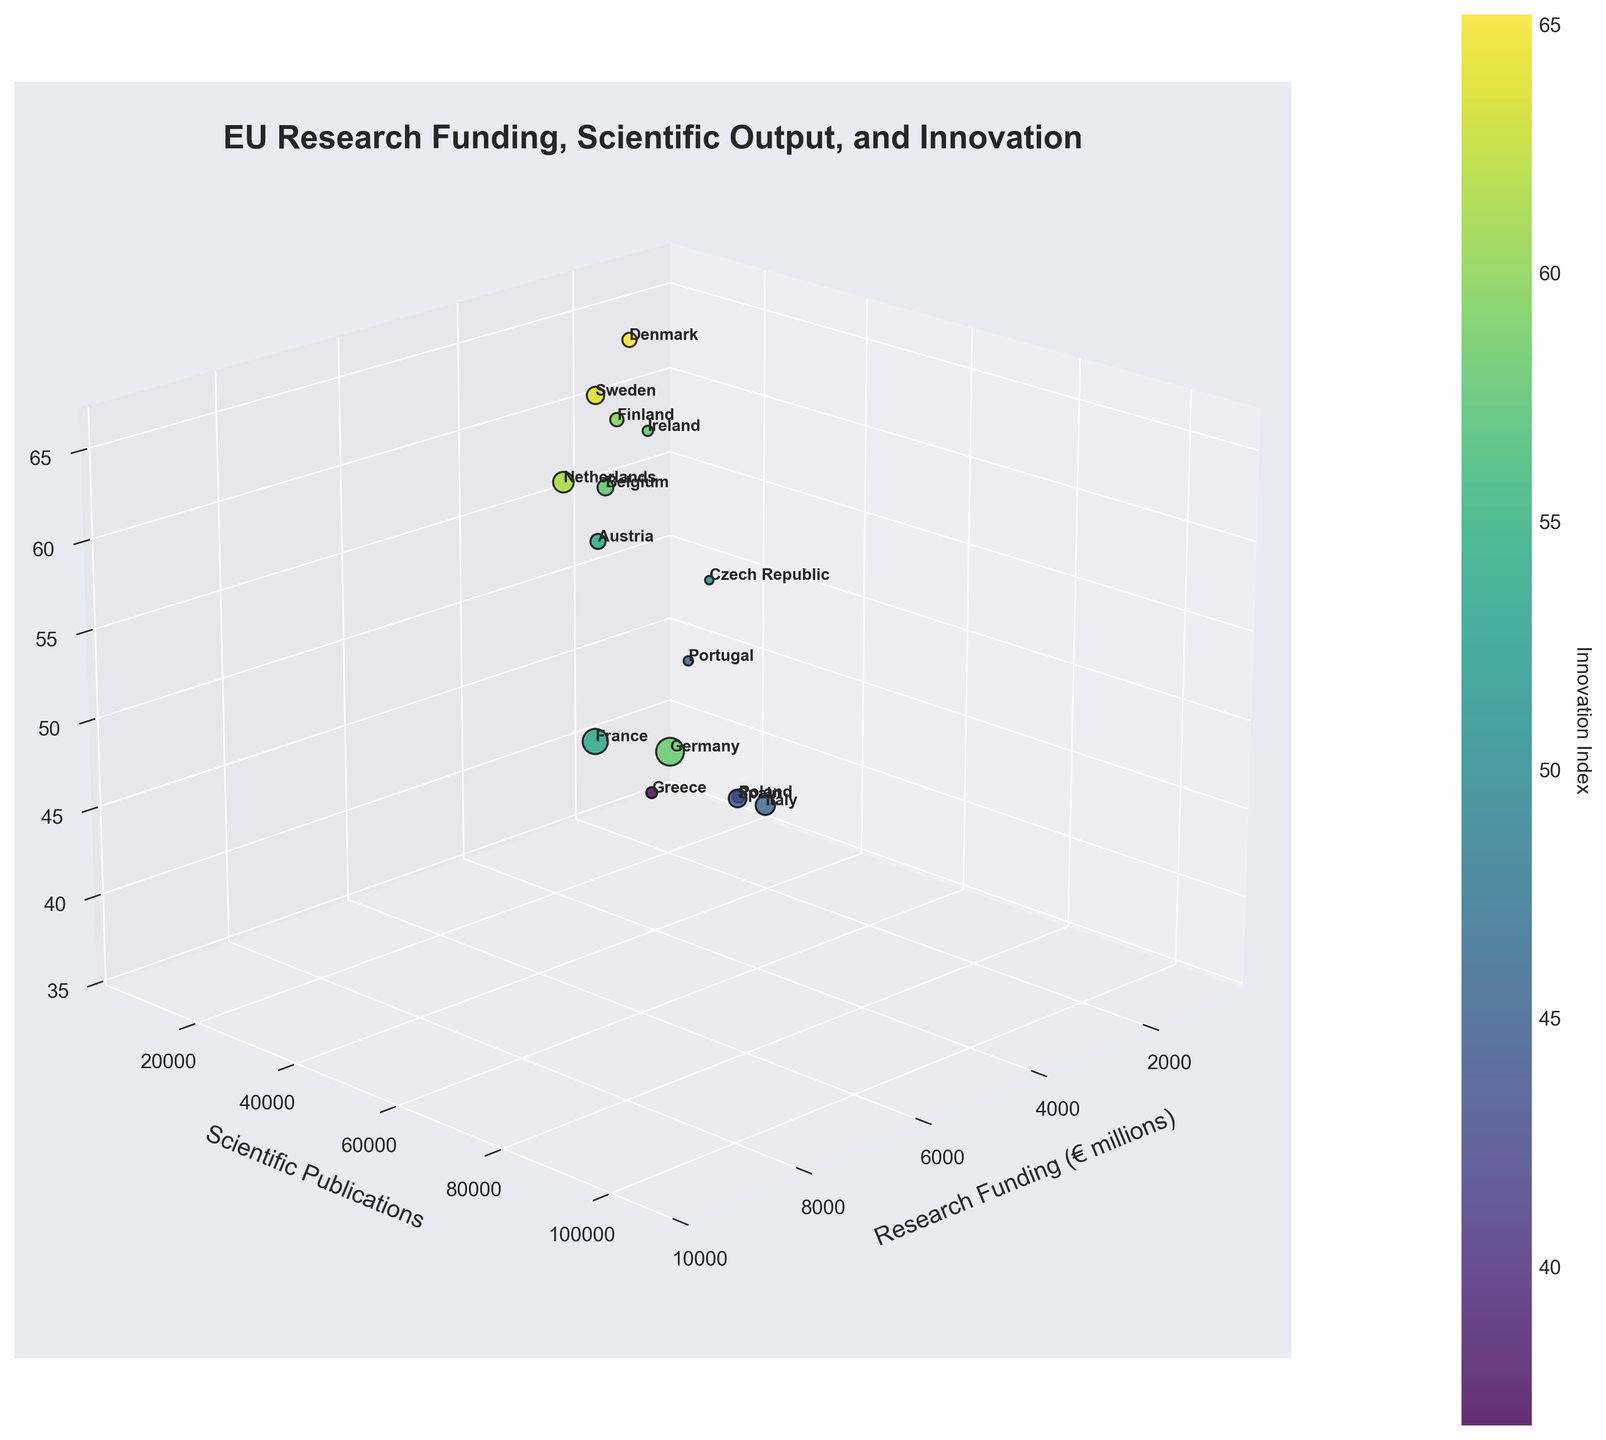Which country has the highest Innovation Index in the data? By visually inspecting the 3D scatter plot, focus on the z-axis which represents the Innovation Index. Identify the highest point on the z-axis and note the associated country.
Answer: Denmark What's the title of the figure? Look at the top of the figure where the title is displayed prominently.
Answer: EU Research Funding, Scientific Output, and Innovation How many countries are represented in the figure? Count the number of labeled points (or countries) represented in the scatter plot.
Answer: 15 Which country has the largest scientific output for the smallest research funding? Analyze the scatter plot to find the point with the smallest x-value (Research Funding) and then compare its y-value (Scientific Publications).
Answer: Poland What is the average Innovation Index of the countries with Research Funding above €5000 million? Identify the countries with Research Funding above €5000 million (Germany, France, Netherlands). Sum their Innovation Index values and divide by the number of these countries. The values are 58.2 (Germany), 53.4 (France), and 61.4 (Netherlands). Thus, the average is (58.2 + 53.4 + 61.4) / 3.
Answer: 57.67 Which country stands out on the scatter plot for having high scientific publications but low research funding? Look for a point with a high y-value (Scientific Publications) and a relatively low x-value (Research Funding).
Answer: Poland What is the range of Scientific Publications for the countries shown? Identify the minimum and maximum values on the y-axis by observing the scatter plot. The minimum is 8000 (Ireland) and the maximum is 105000 (Germany). Subtract the minimum from the maximum to find the range.
Answer: 97000 Compare the Innovation Index of Germany and France, and determine which is higher. Observe the z-values for Germany and France in the scatter plot. Note that Germany has an Innovation Index of 58.2, while France has 53.4.
Answer: Germany How does the size of the markers relate to the data points in the figure? By visual inspection, the size of the markers directly corresponds to the amount of Research Funding (x-axis value); larger markers indicate higher research funding amounts.
Answer: Correlates with Research Funding 